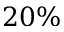Convert formula to latex. <formula><loc_0><loc_0><loc_500><loc_500>2 0 \%</formula> 